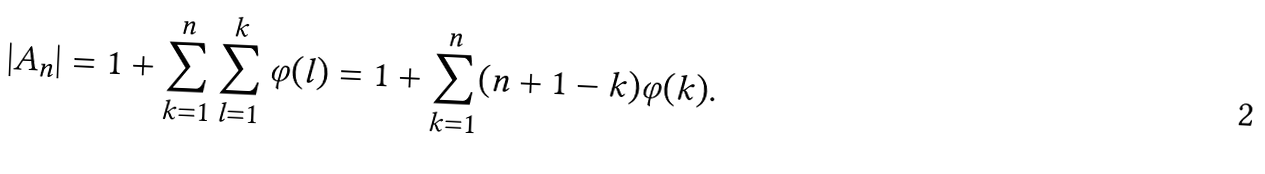<formula> <loc_0><loc_0><loc_500><loc_500>| A _ { n } | = 1 + \sum _ { k = 1 } ^ { n } \sum _ { l = 1 } ^ { k } \varphi ( l ) = 1 + \sum _ { k = 1 } ^ { n } ( n + 1 - k ) \varphi ( k ) .</formula> 